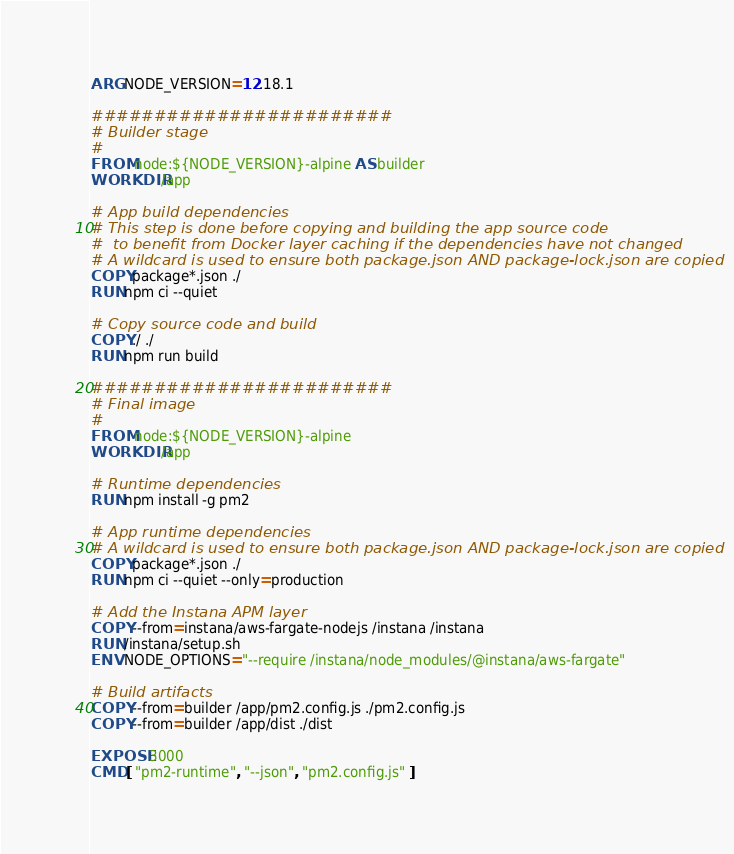Convert code to text. <code><loc_0><loc_0><loc_500><loc_500><_Dockerfile_>ARG NODE_VERSION=12.18.1

########################
# Builder stage
#
FROM node:${NODE_VERSION}-alpine AS builder
WORKDIR /app

# App build dependencies
# This step is done before copying and building the app source code
#  to benefit from Docker layer caching if the dependencies have not changed
# A wildcard is used to ensure both package.json AND package-lock.json are copied
COPY package*.json ./
RUN npm ci --quiet

# Copy source code and build
COPY ./ ./
RUN npm run build

########################
# Final image
#
FROM node:${NODE_VERSION}-alpine
WORKDIR /app

# Runtime dependencies
RUN npm install -g pm2

# App runtime dependencies
# A wildcard is used to ensure both package.json AND package-lock.json are copied
COPY package*.json ./
RUN npm ci --quiet --only=production

# Add the Instana APM layer
COPY --from=instana/aws-fargate-nodejs /instana /instana
RUN /instana/setup.sh
ENV NODE_OPTIONS="--require /instana/node_modules/@instana/aws-fargate"

# Build artifacts
COPY --from=builder /app/pm2.config.js ./pm2.config.js
COPY --from=builder /app/dist ./dist

EXPOSE 3000
CMD [ "pm2-runtime", "--json", "pm2.config.js" ]
</code> 